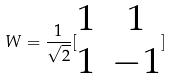<formula> <loc_0><loc_0><loc_500><loc_500>W = \frac { 1 } { \sqrt { 2 } } [ \begin{matrix} 1 & 1 \\ 1 & - 1 \end{matrix} ]</formula> 